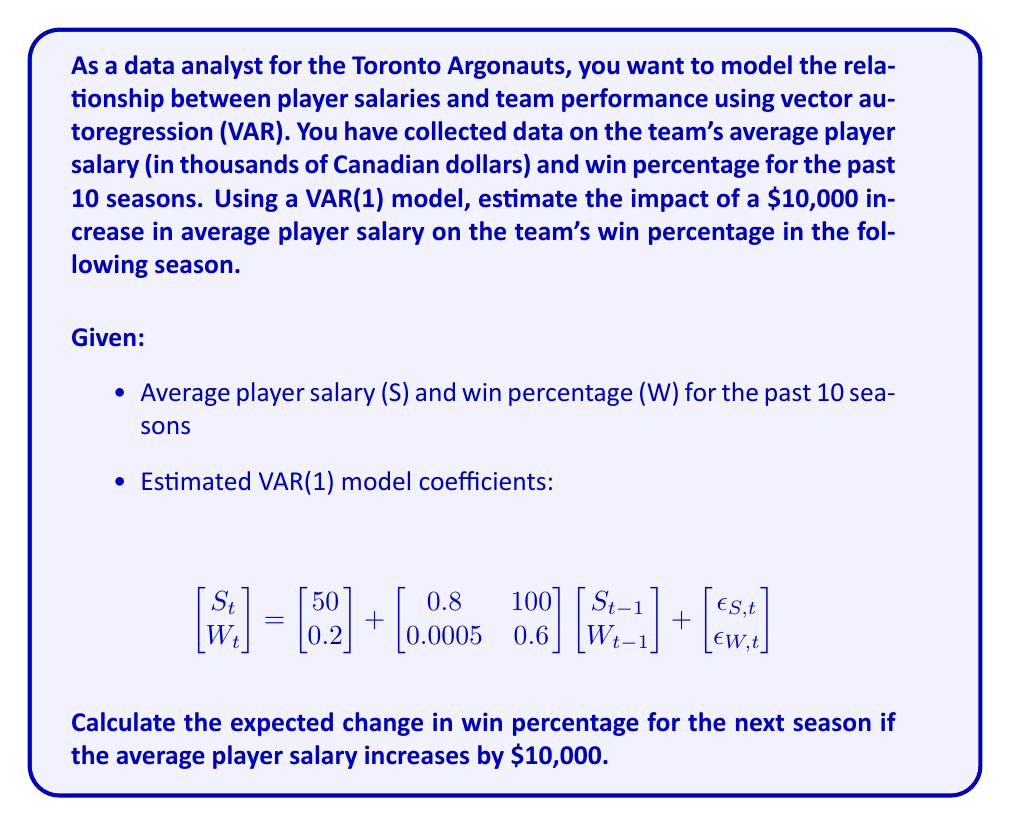Give your solution to this math problem. To solve this problem, we'll use the vector autoregression (VAR) model given in the question. We're interested in the impact of a salary increase on the win percentage in the following season.

1) The VAR(1) model is given as:

   $$\begin{bmatrix} S_t \\ W_t \end{bmatrix} = \begin{bmatrix} 50 \\ 0.2 \end{bmatrix} + \begin{bmatrix} 0.8 & 100 \\ 0.0005 & 0.6 \end{bmatrix} \begin{bmatrix} S_{t-1} \\ W_{t-1} \end{bmatrix} + \begin{bmatrix} \epsilon_{S,t} \\ \epsilon_{W,t} \end{bmatrix}$$

2) We're interested in the effect on $W_t$ (win percentage) given a change in $S_{t-1}$ (previous season's salary). Looking at the second row of the coefficient matrix:

   $W_t = 0.2 + 0.0005S_{t-1} + 0.6W_{t-1} + \epsilon_{W,t}$

3) The coefficient 0.0005 represents the effect of the previous season's salary on the current season's win percentage. However, this is for a $1,000 increase in salary (as the salary is in thousands of dollars).

4) For a $10,000 increase, we multiply this coefficient by 10:

   $0.0005 * 10 = 0.005$

5) This means that a $10,000 increase in the average player salary is expected to increase the win percentage by 0.005 (or 0.5 percentage points) in the following season, holding all else constant.

Note: This interpretation assumes the model is correctly specified and that the relationship is causal. In reality, many other factors could influence win percentage, and the relationship between salary and performance may be more complex.
Answer: A $10,000 increase in average player salary is expected to increase the Toronto Argonauts' win percentage by 0.005 (0.5 percentage points) in the following season, according to the VAR(1) model. 